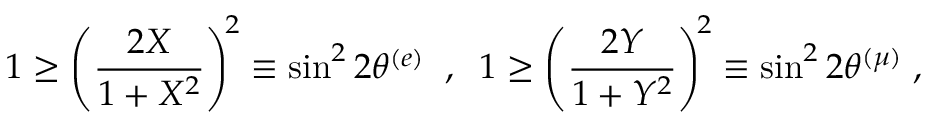<formula> <loc_0><loc_0><loc_500><loc_500>1 \geq \left ( \frac { 2 X } { 1 + X ^ { 2 } } \right ) ^ { \, 2 } \equiv \sin ^ { 2 } 2 \theta ^ { ( e ) } \, , \, 1 \geq \left ( \frac { 2 Y } { 1 + Y ^ { 2 } } \right ) ^ { \, 2 } \equiv \sin ^ { 2 } 2 \theta ^ { ( \mu ) } \, ,</formula> 